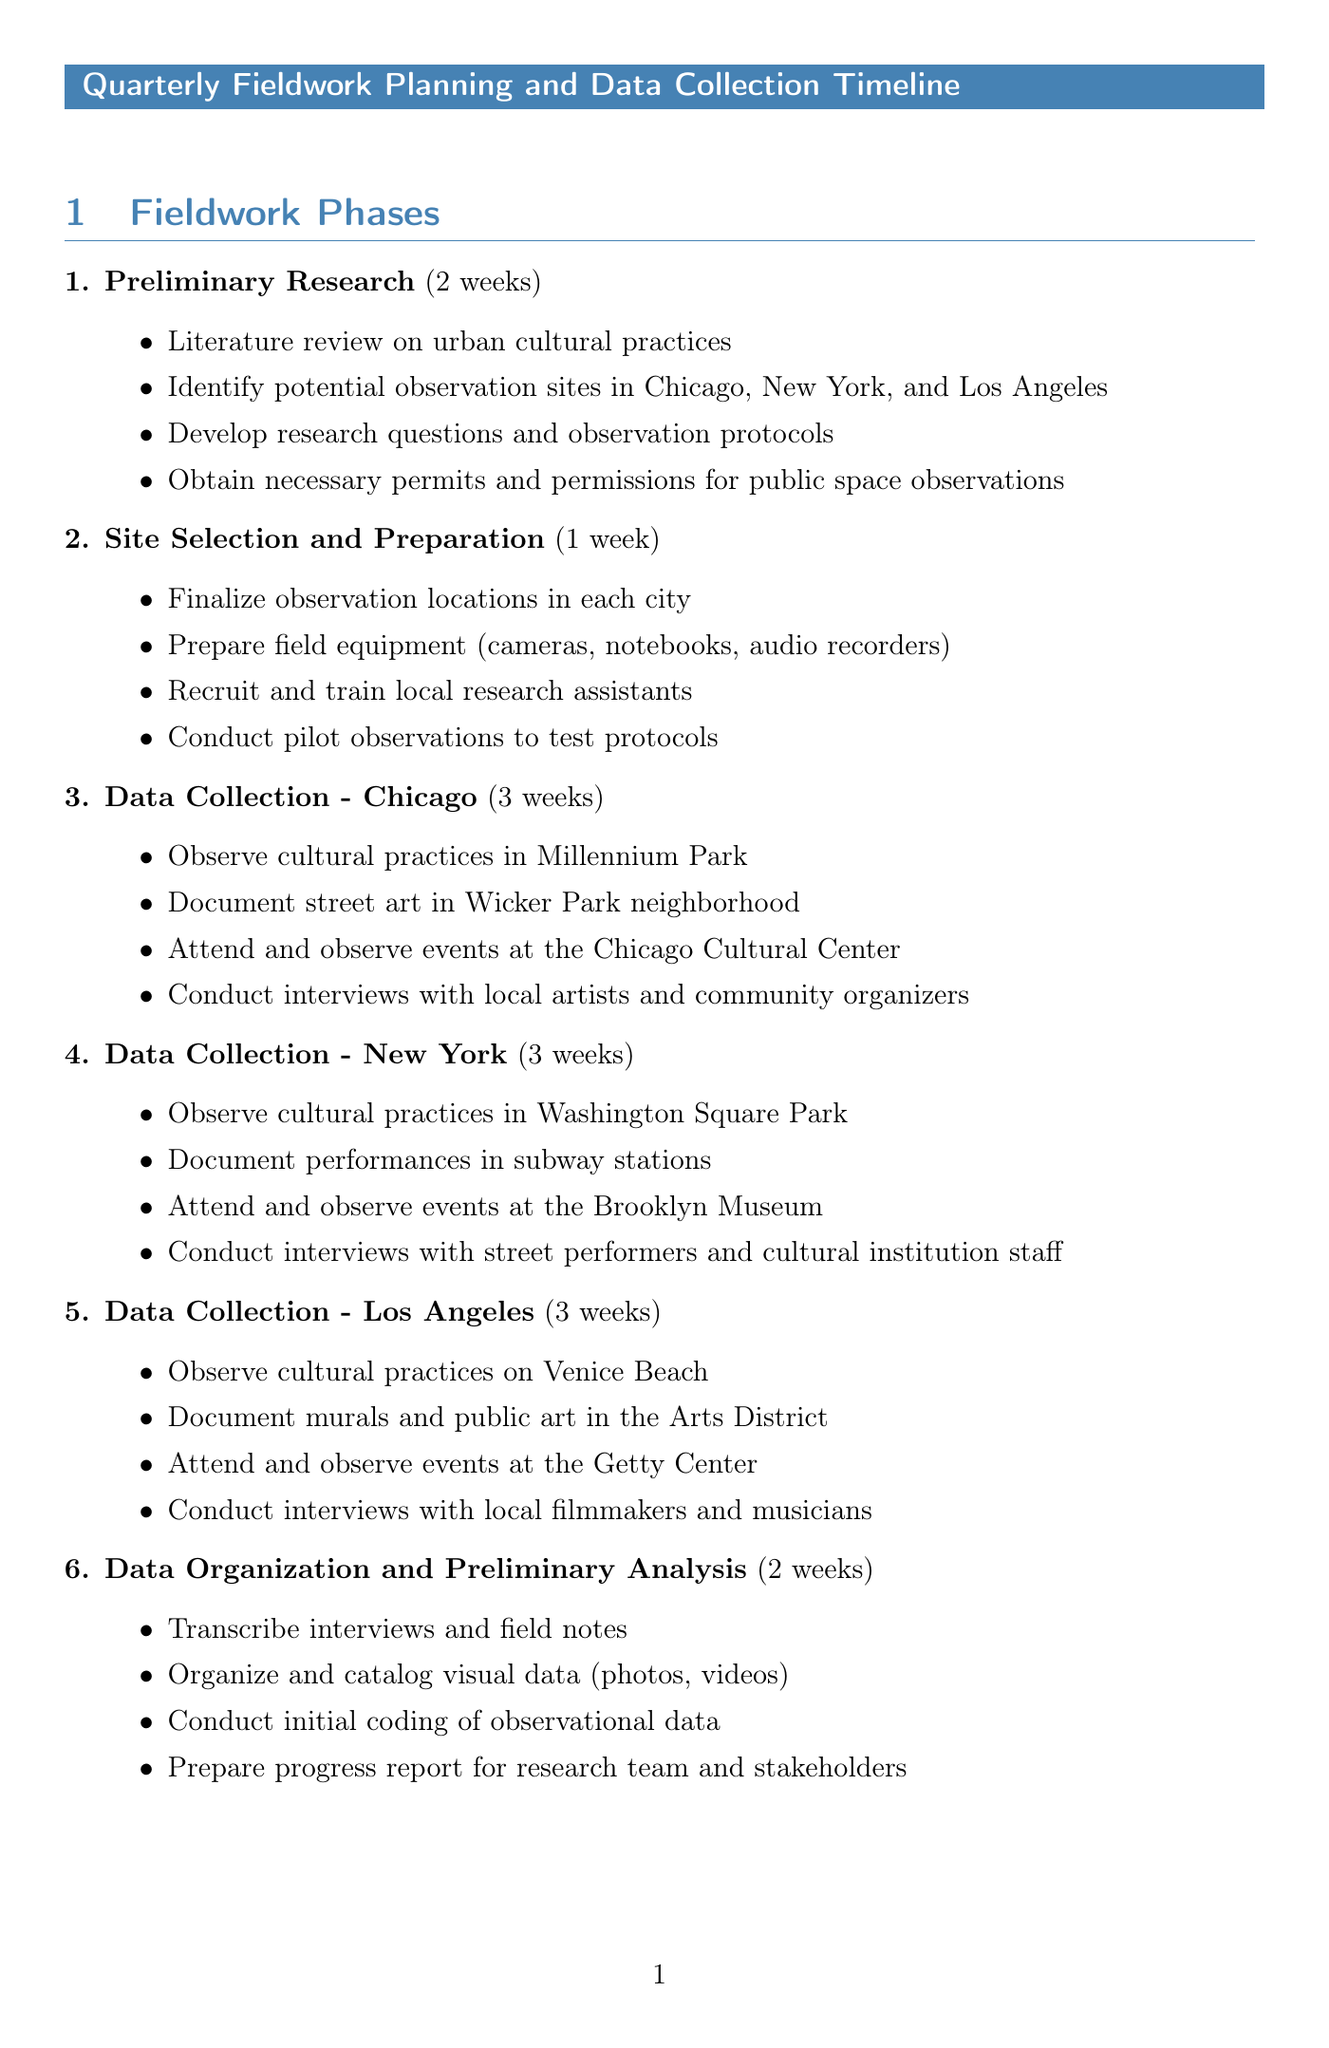What is the duration of the Preliminary Research phase? The duration of the Preliminary Research phase is stated in the document as 2 weeks.
Answer: 2 weeks How many cities are included in the data collection phase? The document mentions three cities: Chicago, New York, and Los Angeles for data collection.
Answer: Three What activities are planned for the data collection in Los Angeles? The document outlines specific activities such as observing cultural practices on Venice Beach and conducting interviews with local filmmakers.
Answer: Observe cultural practices on Venice Beach, document murals and public art in the Arts District, attend events at the Getty Center, conduct interviews with local filmmakers and musicians When is the final data collection review scheduled? The final data collection review date is provided as 1 week after completion of Los Angeles data collection.
Answer: 1 week after completion of Los Angeles data collection What is one potential challenge mentioned in the document? The document lists challenges such as weather-related disruptions to outdoor observations, which outlines potential risks for data collection.
Answer: Weather-related disruptions to outdoor observations Who is a collaboration partner mentioned in the document? The document refers to the Urban Studies Department at the University of Chicago as a collaboration partner for a guest lecture on field research methods.
Answer: Urban Studies Department, University of Chicago What is the duration of the Data Organization and Preliminary Analysis phase? The document specifies that the Data Organization and Preliminary Analysis phase lasts for 2 weeks.
Answer: 2 weeks How many weeks are allocated for data collection in New York? The document clearly states the duration for data collection in New York, which is 3 weeks.
Answer: 3 weeks 